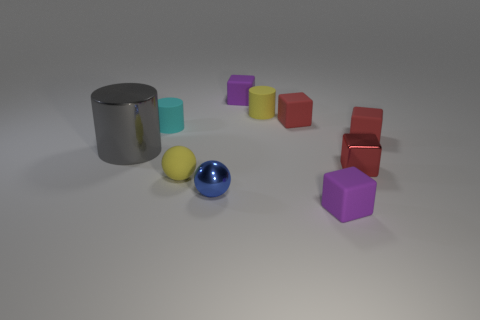Are there any other things that have the same material as the tiny cyan cylinder?
Your answer should be compact. Yes. What number of objects are purple rubber cubes on the left side of the yellow cylinder or small rubber cubes that are behind the small yellow sphere?
Your answer should be compact. 3. Does the blue thing have the same material as the sphere left of the small shiny sphere?
Provide a succinct answer. No. There is a metal object that is right of the big gray metal cylinder and behind the blue sphere; what is its shape?
Make the answer very short. Cube. What number of other objects are the same color as the tiny metallic cube?
Keep it short and to the point. 2. There is a gray object; what shape is it?
Give a very brief answer. Cylinder. What color is the small rubber object behind the tiny yellow rubber object that is behind the rubber sphere?
Give a very brief answer. Purple. Do the shiny cube and the matte block that is behind the yellow rubber cylinder have the same color?
Ensure brevity in your answer.  No. What is the material of the cylinder that is both on the left side of the tiny blue shiny thing and to the right of the gray object?
Your answer should be compact. Rubber. Are there any gray objects of the same size as the yellow sphere?
Your answer should be very brief. No. 